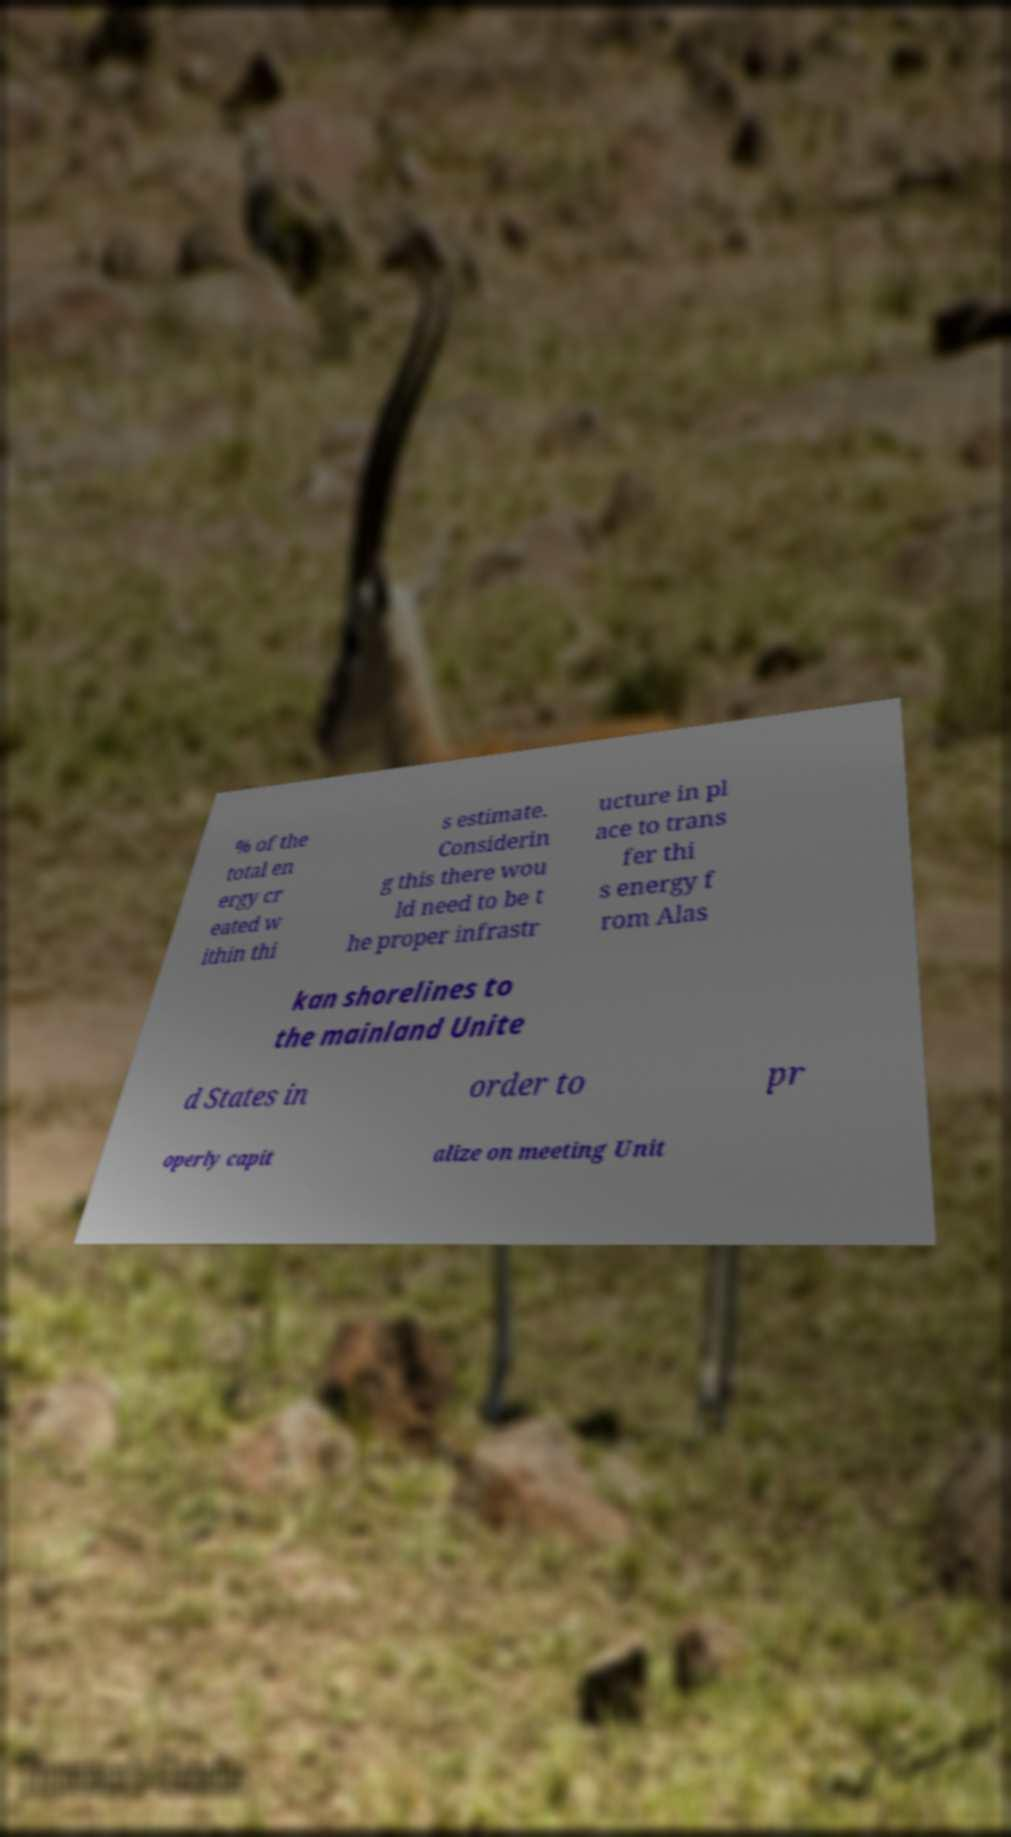Please read and relay the text visible in this image. What does it say? % of the total en ergy cr eated w ithin thi s estimate. Considerin g this there wou ld need to be t he proper infrastr ucture in pl ace to trans fer thi s energy f rom Alas kan shorelines to the mainland Unite d States in order to pr operly capit alize on meeting Unit 